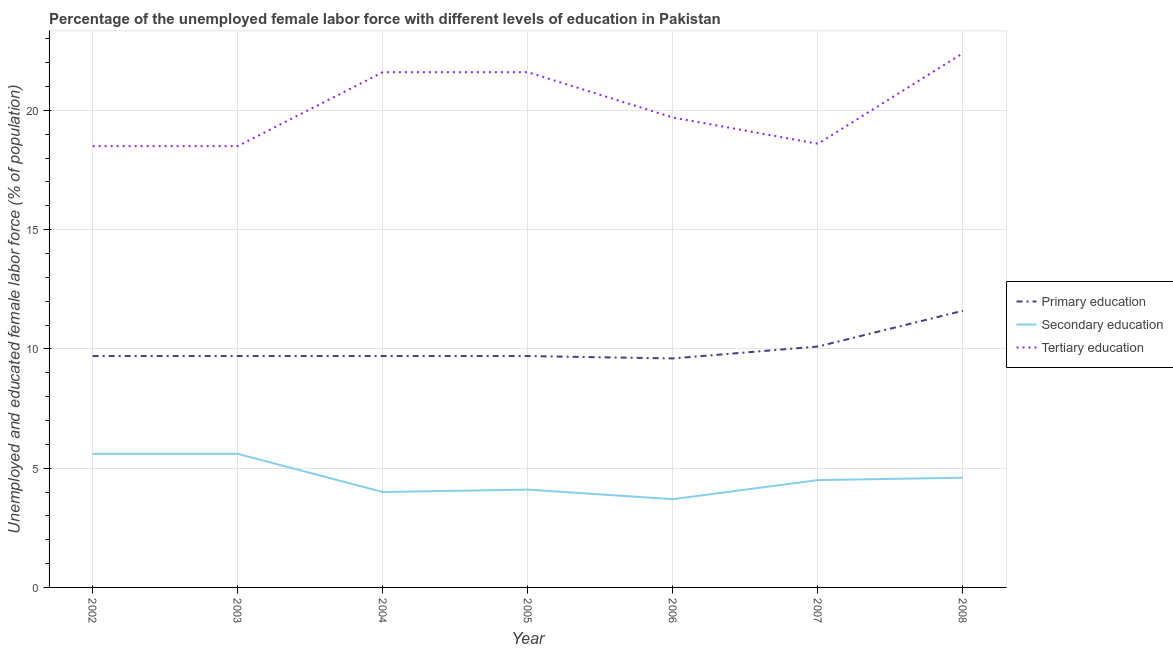How many different coloured lines are there?
Provide a short and direct response. 3. Does the line corresponding to percentage of female labor force who received tertiary education intersect with the line corresponding to percentage of female labor force who received secondary education?
Give a very brief answer. No. What is the percentage of female labor force who received primary education in 2006?
Offer a terse response. 9.6. Across all years, what is the maximum percentage of female labor force who received primary education?
Provide a succinct answer. 11.6. Across all years, what is the minimum percentage of female labor force who received tertiary education?
Your response must be concise. 18.5. In which year was the percentage of female labor force who received secondary education maximum?
Give a very brief answer. 2002. In which year was the percentage of female labor force who received primary education minimum?
Ensure brevity in your answer.  2006. What is the total percentage of female labor force who received secondary education in the graph?
Your answer should be very brief. 32.1. What is the difference between the percentage of female labor force who received tertiary education in 2003 and that in 2008?
Make the answer very short. -3.9. What is the difference between the percentage of female labor force who received tertiary education in 2005 and the percentage of female labor force who received secondary education in 2003?
Give a very brief answer. 16. What is the average percentage of female labor force who received secondary education per year?
Provide a succinct answer. 4.59. In the year 2007, what is the difference between the percentage of female labor force who received tertiary education and percentage of female labor force who received secondary education?
Your answer should be very brief. 14.1. In how many years, is the percentage of female labor force who received tertiary education greater than 22 %?
Offer a terse response. 1. What is the ratio of the percentage of female labor force who received tertiary education in 2003 to that in 2006?
Provide a short and direct response. 0.94. Is the percentage of female labor force who received tertiary education in 2002 less than that in 2003?
Your answer should be compact. No. What is the difference between the highest and the lowest percentage of female labor force who received tertiary education?
Provide a short and direct response. 3.9. In how many years, is the percentage of female labor force who received tertiary education greater than the average percentage of female labor force who received tertiary education taken over all years?
Your answer should be compact. 3. Is the sum of the percentage of female labor force who received secondary education in 2005 and 2008 greater than the maximum percentage of female labor force who received primary education across all years?
Ensure brevity in your answer.  No. Is it the case that in every year, the sum of the percentage of female labor force who received primary education and percentage of female labor force who received secondary education is greater than the percentage of female labor force who received tertiary education?
Make the answer very short. No. Does the percentage of female labor force who received tertiary education monotonically increase over the years?
Ensure brevity in your answer.  No. How many years are there in the graph?
Make the answer very short. 7. What is the difference between two consecutive major ticks on the Y-axis?
Give a very brief answer. 5. Are the values on the major ticks of Y-axis written in scientific E-notation?
Your answer should be very brief. No. Does the graph contain any zero values?
Give a very brief answer. No. Does the graph contain grids?
Offer a very short reply. Yes. What is the title of the graph?
Provide a succinct answer. Percentage of the unemployed female labor force with different levels of education in Pakistan. Does "Ages 20-60" appear as one of the legend labels in the graph?
Give a very brief answer. No. What is the label or title of the X-axis?
Offer a very short reply. Year. What is the label or title of the Y-axis?
Keep it short and to the point. Unemployed and educated female labor force (% of population). What is the Unemployed and educated female labor force (% of population) in Primary education in 2002?
Provide a short and direct response. 9.7. What is the Unemployed and educated female labor force (% of population) in Secondary education in 2002?
Ensure brevity in your answer.  5.6. What is the Unemployed and educated female labor force (% of population) in Tertiary education in 2002?
Provide a short and direct response. 18.5. What is the Unemployed and educated female labor force (% of population) of Primary education in 2003?
Provide a succinct answer. 9.7. What is the Unemployed and educated female labor force (% of population) of Secondary education in 2003?
Your response must be concise. 5.6. What is the Unemployed and educated female labor force (% of population) in Tertiary education in 2003?
Offer a very short reply. 18.5. What is the Unemployed and educated female labor force (% of population) of Primary education in 2004?
Your answer should be very brief. 9.7. What is the Unemployed and educated female labor force (% of population) in Secondary education in 2004?
Offer a very short reply. 4. What is the Unemployed and educated female labor force (% of population) in Tertiary education in 2004?
Make the answer very short. 21.6. What is the Unemployed and educated female labor force (% of population) in Primary education in 2005?
Provide a short and direct response. 9.7. What is the Unemployed and educated female labor force (% of population) in Secondary education in 2005?
Ensure brevity in your answer.  4.1. What is the Unemployed and educated female labor force (% of population) in Tertiary education in 2005?
Your answer should be very brief. 21.6. What is the Unemployed and educated female labor force (% of population) of Primary education in 2006?
Offer a very short reply. 9.6. What is the Unemployed and educated female labor force (% of population) in Secondary education in 2006?
Offer a very short reply. 3.7. What is the Unemployed and educated female labor force (% of population) of Tertiary education in 2006?
Keep it short and to the point. 19.7. What is the Unemployed and educated female labor force (% of population) in Primary education in 2007?
Make the answer very short. 10.1. What is the Unemployed and educated female labor force (% of population) in Tertiary education in 2007?
Provide a short and direct response. 18.6. What is the Unemployed and educated female labor force (% of population) of Primary education in 2008?
Offer a very short reply. 11.6. What is the Unemployed and educated female labor force (% of population) of Secondary education in 2008?
Provide a short and direct response. 4.6. What is the Unemployed and educated female labor force (% of population) of Tertiary education in 2008?
Ensure brevity in your answer.  22.4. Across all years, what is the maximum Unemployed and educated female labor force (% of population) in Primary education?
Make the answer very short. 11.6. Across all years, what is the maximum Unemployed and educated female labor force (% of population) of Secondary education?
Offer a terse response. 5.6. Across all years, what is the maximum Unemployed and educated female labor force (% of population) in Tertiary education?
Your answer should be very brief. 22.4. Across all years, what is the minimum Unemployed and educated female labor force (% of population) in Primary education?
Offer a very short reply. 9.6. Across all years, what is the minimum Unemployed and educated female labor force (% of population) of Secondary education?
Make the answer very short. 3.7. What is the total Unemployed and educated female labor force (% of population) of Primary education in the graph?
Ensure brevity in your answer.  70.1. What is the total Unemployed and educated female labor force (% of population) in Secondary education in the graph?
Keep it short and to the point. 32.1. What is the total Unemployed and educated female labor force (% of population) of Tertiary education in the graph?
Provide a short and direct response. 140.9. What is the difference between the Unemployed and educated female labor force (% of population) in Secondary education in 2002 and that in 2003?
Offer a very short reply. 0. What is the difference between the Unemployed and educated female labor force (% of population) of Tertiary education in 2002 and that in 2003?
Your answer should be very brief. 0. What is the difference between the Unemployed and educated female labor force (% of population) in Primary education in 2002 and that in 2004?
Provide a short and direct response. 0. What is the difference between the Unemployed and educated female labor force (% of population) in Secondary education in 2002 and that in 2004?
Provide a succinct answer. 1.6. What is the difference between the Unemployed and educated female labor force (% of population) in Secondary education in 2002 and that in 2005?
Make the answer very short. 1.5. What is the difference between the Unemployed and educated female labor force (% of population) in Primary education in 2002 and that in 2006?
Your answer should be compact. 0.1. What is the difference between the Unemployed and educated female labor force (% of population) of Tertiary education in 2002 and that in 2006?
Provide a succinct answer. -1.2. What is the difference between the Unemployed and educated female labor force (% of population) of Primary education in 2002 and that in 2007?
Provide a short and direct response. -0.4. What is the difference between the Unemployed and educated female labor force (% of population) in Primary education in 2002 and that in 2008?
Ensure brevity in your answer.  -1.9. What is the difference between the Unemployed and educated female labor force (% of population) of Tertiary education in 2003 and that in 2004?
Give a very brief answer. -3.1. What is the difference between the Unemployed and educated female labor force (% of population) of Primary education in 2003 and that in 2005?
Offer a terse response. 0. What is the difference between the Unemployed and educated female labor force (% of population) in Secondary education in 2003 and that in 2005?
Your answer should be very brief. 1.5. What is the difference between the Unemployed and educated female labor force (% of population) in Primary education in 2003 and that in 2006?
Your answer should be very brief. 0.1. What is the difference between the Unemployed and educated female labor force (% of population) of Secondary education in 2003 and that in 2006?
Provide a short and direct response. 1.9. What is the difference between the Unemployed and educated female labor force (% of population) of Primary education in 2003 and that in 2007?
Provide a succinct answer. -0.4. What is the difference between the Unemployed and educated female labor force (% of population) in Secondary education in 2003 and that in 2007?
Offer a very short reply. 1.1. What is the difference between the Unemployed and educated female labor force (% of population) in Primary education in 2003 and that in 2008?
Your answer should be very brief. -1.9. What is the difference between the Unemployed and educated female labor force (% of population) of Secondary education in 2003 and that in 2008?
Your answer should be compact. 1. What is the difference between the Unemployed and educated female labor force (% of population) of Primary education in 2004 and that in 2005?
Provide a succinct answer. 0. What is the difference between the Unemployed and educated female labor force (% of population) of Secondary education in 2004 and that in 2005?
Provide a short and direct response. -0.1. What is the difference between the Unemployed and educated female labor force (% of population) in Tertiary education in 2004 and that in 2005?
Your answer should be compact. 0. What is the difference between the Unemployed and educated female labor force (% of population) in Primary education in 2004 and that in 2006?
Offer a very short reply. 0.1. What is the difference between the Unemployed and educated female labor force (% of population) in Secondary education in 2004 and that in 2006?
Provide a short and direct response. 0.3. What is the difference between the Unemployed and educated female labor force (% of population) of Tertiary education in 2004 and that in 2006?
Give a very brief answer. 1.9. What is the difference between the Unemployed and educated female labor force (% of population) of Primary education in 2004 and that in 2007?
Offer a very short reply. -0.4. What is the difference between the Unemployed and educated female labor force (% of population) in Tertiary education in 2004 and that in 2007?
Your response must be concise. 3. What is the difference between the Unemployed and educated female labor force (% of population) in Primary education in 2004 and that in 2008?
Offer a terse response. -1.9. What is the difference between the Unemployed and educated female labor force (% of population) in Tertiary education in 2004 and that in 2008?
Offer a very short reply. -0.8. What is the difference between the Unemployed and educated female labor force (% of population) of Primary education in 2005 and that in 2006?
Offer a terse response. 0.1. What is the difference between the Unemployed and educated female labor force (% of population) of Secondary education in 2005 and that in 2006?
Make the answer very short. 0.4. What is the difference between the Unemployed and educated female labor force (% of population) of Tertiary education in 2005 and that in 2006?
Make the answer very short. 1.9. What is the difference between the Unemployed and educated female labor force (% of population) in Secondary education in 2005 and that in 2008?
Provide a short and direct response. -0.5. What is the difference between the Unemployed and educated female labor force (% of population) of Primary education in 2006 and that in 2007?
Keep it short and to the point. -0.5. What is the difference between the Unemployed and educated female labor force (% of population) of Secondary education in 2006 and that in 2007?
Provide a succinct answer. -0.8. What is the difference between the Unemployed and educated female labor force (% of population) of Tertiary education in 2006 and that in 2007?
Provide a short and direct response. 1.1. What is the difference between the Unemployed and educated female labor force (% of population) in Tertiary education in 2007 and that in 2008?
Provide a short and direct response. -3.8. What is the difference between the Unemployed and educated female labor force (% of population) of Primary education in 2002 and the Unemployed and educated female labor force (% of population) of Secondary education in 2003?
Your answer should be very brief. 4.1. What is the difference between the Unemployed and educated female labor force (% of population) in Secondary education in 2002 and the Unemployed and educated female labor force (% of population) in Tertiary education in 2003?
Give a very brief answer. -12.9. What is the difference between the Unemployed and educated female labor force (% of population) in Primary education in 2002 and the Unemployed and educated female labor force (% of population) in Secondary education in 2004?
Provide a short and direct response. 5.7. What is the difference between the Unemployed and educated female labor force (% of population) in Primary education in 2002 and the Unemployed and educated female labor force (% of population) in Tertiary education in 2004?
Offer a very short reply. -11.9. What is the difference between the Unemployed and educated female labor force (% of population) in Primary education in 2002 and the Unemployed and educated female labor force (% of population) in Secondary education in 2005?
Provide a succinct answer. 5.6. What is the difference between the Unemployed and educated female labor force (% of population) of Primary education in 2002 and the Unemployed and educated female labor force (% of population) of Tertiary education in 2005?
Offer a terse response. -11.9. What is the difference between the Unemployed and educated female labor force (% of population) of Primary education in 2002 and the Unemployed and educated female labor force (% of population) of Tertiary education in 2006?
Offer a terse response. -10. What is the difference between the Unemployed and educated female labor force (% of population) in Secondary education in 2002 and the Unemployed and educated female labor force (% of population) in Tertiary education in 2006?
Ensure brevity in your answer.  -14.1. What is the difference between the Unemployed and educated female labor force (% of population) in Primary education in 2002 and the Unemployed and educated female labor force (% of population) in Secondary education in 2008?
Provide a succinct answer. 5.1. What is the difference between the Unemployed and educated female labor force (% of population) of Primary education in 2002 and the Unemployed and educated female labor force (% of population) of Tertiary education in 2008?
Make the answer very short. -12.7. What is the difference between the Unemployed and educated female labor force (% of population) in Secondary education in 2002 and the Unemployed and educated female labor force (% of population) in Tertiary education in 2008?
Your answer should be compact. -16.8. What is the difference between the Unemployed and educated female labor force (% of population) in Primary education in 2003 and the Unemployed and educated female labor force (% of population) in Secondary education in 2005?
Your response must be concise. 5.6. What is the difference between the Unemployed and educated female labor force (% of population) of Primary education in 2003 and the Unemployed and educated female labor force (% of population) of Tertiary education in 2005?
Ensure brevity in your answer.  -11.9. What is the difference between the Unemployed and educated female labor force (% of population) in Secondary education in 2003 and the Unemployed and educated female labor force (% of population) in Tertiary education in 2005?
Provide a short and direct response. -16. What is the difference between the Unemployed and educated female labor force (% of population) in Primary education in 2003 and the Unemployed and educated female labor force (% of population) in Secondary education in 2006?
Give a very brief answer. 6. What is the difference between the Unemployed and educated female labor force (% of population) of Secondary education in 2003 and the Unemployed and educated female labor force (% of population) of Tertiary education in 2006?
Your response must be concise. -14.1. What is the difference between the Unemployed and educated female labor force (% of population) in Primary education in 2003 and the Unemployed and educated female labor force (% of population) in Tertiary education in 2007?
Your answer should be compact. -8.9. What is the difference between the Unemployed and educated female labor force (% of population) of Primary education in 2003 and the Unemployed and educated female labor force (% of population) of Tertiary education in 2008?
Ensure brevity in your answer.  -12.7. What is the difference between the Unemployed and educated female labor force (% of population) in Secondary education in 2003 and the Unemployed and educated female labor force (% of population) in Tertiary education in 2008?
Offer a terse response. -16.8. What is the difference between the Unemployed and educated female labor force (% of population) in Primary education in 2004 and the Unemployed and educated female labor force (% of population) in Secondary education in 2005?
Provide a succinct answer. 5.6. What is the difference between the Unemployed and educated female labor force (% of population) of Primary education in 2004 and the Unemployed and educated female labor force (% of population) of Tertiary education in 2005?
Your answer should be compact. -11.9. What is the difference between the Unemployed and educated female labor force (% of population) in Secondary education in 2004 and the Unemployed and educated female labor force (% of population) in Tertiary education in 2005?
Your answer should be compact. -17.6. What is the difference between the Unemployed and educated female labor force (% of population) in Primary education in 2004 and the Unemployed and educated female labor force (% of population) in Secondary education in 2006?
Offer a terse response. 6. What is the difference between the Unemployed and educated female labor force (% of population) of Primary education in 2004 and the Unemployed and educated female labor force (% of population) of Tertiary education in 2006?
Ensure brevity in your answer.  -10. What is the difference between the Unemployed and educated female labor force (% of population) of Secondary education in 2004 and the Unemployed and educated female labor force (% of population) of Tertiary education in 2006?
Offer a very short reply. -15.7. What is the difference between the Unemployed and educated female labor force (% of population) in Primary education in 2004 and the Unemployed and educated female labor force (% of population) in Tertiary education in 2007?
Your answer should be very brief. -8.9. What is the difference between the Unemployed and educated female labor force (% of population) in Secondary education in 2004 and the Unemployed and educated female labor force (% of population) in Tertiary education in 2007?
Ensure brevity in your answer.  -14.6. What is the difference between the Unemployed and educated female labor force (% of population) in Primary education in 2004 and the Unemployed and educated female labor force (% of population) in Tertiary education in 2008?
Give a very brief answer. -12.7. What is the difference between the Unemployed and educated female labor force (% of population) in Secondary education in 2004 and the Unemployed and educated female labor force (% of population) in Tertiary education in 2008?
Provide a short and direct response. -18.4. What is the difference between the Unemployed and educated female labor force (% of population) of Secondary education in 2005 and the Unemployed and educated female labor force (% of population) of Tertiary education in 2006?
Your answer should be very brief. -15.6. What is the difference between the Unemployed and educated female labor force (% of population) in Primary education in 2005 and the Unemployed and educated female labor force (% of population) in Secondary education in 2007?
Make the answer very short. 5.2. What is the difference between the Unemployed and educated female labor force (% of population) of Primary education in 2005 and the Unemployed and educated female labor force (% of population) of Tertiary education in 2007?
Your response must be concise. -8.9. What is the difference between the Unemployed and educated female labor force (% of population) of Secondary education in 2005 and the Unemployed and educated female labor force (% of population) of Tertiary education in 2007?
Keep it short and to the point. -14.5. What is the difference between the Unemployed and educated female labor force (% of population) in Primary education in 2005 and the Unemployed and educated female labor force (% of population) in Secondary education in 2008?
Ensure brevity in your answer.  5.1. What is the difference between the Unemployed and educated female labor force (% of population) of Secondary education in 2005 and the Unemployed and educated female labor force (% of population) of Tertiary education in 2008?
Give a very brief answer. -18.3. What is the difference between the Unemployed and educated female labor force (% of population) in Secondary education in 2006 and the Unemployed and educated female labor force (% of population) in Tertiary education in 2007?
Your answer should be compact. -14.9. What is the difference between the Unemployed and educated female labor force (% of population) in Primary education in 2006 and the Unemployed and educated female labor force (% of population) in Secondary education in 2008?
Make the answer very short. 5. What is the difference between the Unemployed and educated female labor force (% of population) of Secondary education in 2006 and the Unemployed and educated female labor force (% of population) of Tertiary education in 2008?
Provide a short and direct response. -18.7. What is the difference between the Unemployed and educated female labor force (% of population) in Primary education in 2007 and the Unemployed and educated female labor force (% of population) in Secondary education in 2008?
Give a very brief answer. 5.5. What is the difference between the Unemployed and educated female labor force (% of population) in Secondary education in 2007 and the Unemployed and educated female labor force (% of population) in Tertiary education in 2008?
Your answer should be very brief. -17.9. What is the average Unemployed and educated female labor force (% of population) in Primary education per year?
Offer a very short reply. 10.01. What is the average Unemployed and educated female labor force (% of population) in Secondary education per year?
Offer a very short reply. 4.59. What is the average Unemployed and educated female labor force (% of population) in Tertiary education per year?
Offer a terse response. 20.13. In the year 2002, what is the difference between the Unemployed and educated female labor force (% of population) in Secondary education and Unemployed and educated female labor force (% of population) in Tertiary education?
Your answer should be very brief. -12.9. In the year 2003, what is the difference between the Unemployed and educated female labor force (% of population) in Primary education and Unemployed and educated female labor force (% of population) in Secondary education?
Ensure brevity in your answer.  4.1. In the year 2003, what is the difference between the Unemployed and educated female labor force (% of population) of Secondary education and Unemployed and educated female labor force (% of population) of Tertiary education?
Offer a terse response. -12.9. In the year 2004, what is the difference between the Unemployed and educated female labor force (% of population) in Primary education and Unemployed and educated female labor force (% of population) in Secondary education?
Give a very brief answer. 5.7. In the year 2004, what is the difference between the Unemployed and educated female labor force (% of population) in Primary education and Unemployed and educated female labor force (% of population) in Tertiary education?
Offer a very short reply. -11.9. In the year 2004, what is the difference between the Unemployed and educated female labor force (% of population) in Secondary education and Unemployed and educated female labor force (% of population) in Tertiary education?
Your response must be concise. -17.6. In the year 2005, what is the difference between the Unemployed and educated female labor force (% of population) of Primary education and Unemployed and educated female labor force (% of population) of Secondary education?
Provide a succinct answer. 5.6. In the year 2005, what is the difference between the Unemployed and educated female labor force (% of population) in Secondary education and Unemployed and educated female labor force (% of population) in Tertiary education?
Make the answer very short. -17.5. In the year 2006, what is the difference between the Unemployed and educated female labor force (% of population) in Primary education and Unemployed and educated female labor force (% of population) in Secondary education?
Provide a succinct answer. 5.9. In the year 2006, what is the difference between the Unemployed and educated female labor force (% of population) in Secondary education and Unemployed and educated female labor force (% of population) in Tertiary education?
Ensure brevity in your answer.  -16. In the year 2007, what is the difference between the Unemployed and educated female labor force (% of population) in Primary education and Unemployed and educated female labor force (% of population) in Tertiary education?
Ensure brevity in your answer.  -8.5. In the year 2007, what is the difference between the Unemployed and educated female labor force (% of population) of Secondary education and Unemployed and educated female labor force (% of population) of Tertiary education?
Offer a very short reply. -14.1. In the year 2008, what is the difference between the Unemployed and educated female labor force (% of population) of Primary education and Unemployed and educated female labor force (% of population) of Tertiary education?
Offer a very short reply. -10.8. In the year 2008, what is the difference between the Unemployed and educated female labor force (% of population) of Secondary education and Unemployed and educated female labor force (% of population) of Tertiary education?
Provide a short and direct response. -17.8. What is the ratio of the Unemployed and educated female labor force (% of population) in Secondary education in 2002 to that in 2003?
Provide a succinct answer. 1. What is the ratio of the Unemployed and educated female labor force (% of population) in Tertiary education in 2002 to that in 2003?
Your response must be concise. 1. What is the ratio of the Unemployed and educated female labor force (% of population) in Secondary education in 2002 to that in 2004?
Provide a succinct answer. 1.4. What is the ratio of the Unemployed and educated female labor force (% of population) of Tertiary education in 2002 to that in 2004?
Make the answer very short. 0.86. What is the ratio of the Unemployed and educated female labor force (% of population) of Primary education in 2002 to that in 2005?
Your answer should be very brief. 1. What is the ratio of the Unemployed and educated female labor force (% of population) in Secondary education in 2002 to that in 2005?
Keep it short and to the point. 1.37. What is the ratio of the Unemployed and educated female labor force (% of population) in Tertiary education in 2002 to that in 2005?
Offer a terse response. 0.86. What is the ratio of the Unemployed and educated female labor force (% of population) in Primary education in 2002 to that in 2006?
Your answer should be very brief. 1.01. What is the ratio of the Unemployed and educated female labor force (% of population) in Secondary education in 2002 to that in 2006?
Give a very brief answer. 1.51. What is the ratio of the Unemployed and educated female labor force (% of population) of Tertiary education in 2002 to that in 2006?
Offer a terse response. 0.94. What is the ratio of the Unemployed and educated female labor force (% of population) of Primary education in 2002 to that in 2007?
Your response must be concise. 0.96. What is the ratio of the Unemployed and educated female labor force (% of population) of Secondary education in 2002 to that in 2007?
Make the answer very short. 1.24. What is the ratio of the Unemployed and educated female labor force (% of population) in Tertiary education in 2002 to that in 2007?
Provide a short and direct response. 0.99. What is the ratio of the Unemployed and educated female labor force (% of population) of Primary education in 2002 to that in 2008?
Make the answer very short. 0.84. What is the ratio of the Unemployed and educated female labor force (% of population) of Secondary education in 2002 to that in 2008?
Your response must be concise. 1.22. What is the ratio of the Unemployed and educated female labor force (% of population) of Tertiary education in 2002 to that in 2008?
Your response must be concise. 0.83. What is the ratio of the Unemployed and educated female labor force (% of population) in Primary education in 2003 to that in 2004?
Your response must be concise. 1. What is the ratio of the Unemployed and educated female labor force (% of population) of Secondary education in 2003 to that in 2004?
Ensure brevity in your answer.  1.4. What is the ratio of the Unemployed and educated female labor force (% of population) in Tertiary education in 2003 to that in 2004?
Keep it short and to the point. 0.86. What is the ratio of the Unemployed and educated female labor force (% of population) in Primary education in 2003 to that in 2005?
Keep it short and to the point. 1. What is the ratio of the Unemployed and educated female labor force (% of population) in Secondary education in 2003 to that in 2005?
Offer a very short reply. 1.37. What is the ratio of the Unemployed and educated female labor force (% of population) of Tertiary education in 2003 to that in 2005?
Keep it short and to the point. 0.86. What is the ratio of the Unemployed and educated female labor force (% of population) of Primary education in 2003 to that in 2006?
Your response must be concise. 1.01. What is the ratio of the Unemployed and educated female labor force (% of population) of Secondary education in 2003 to that in 2006?
Keep it short and to the point. 1.51. What is the ratio of the Unemployed and educated female labor force (% of population) in Tertiary education in 2003 to that in 2006?
Give a very brief answer. 0.94. What is the ratio of the Unemployed and educated female labor force (% of population) in Primary education in 2003 to that in 2007?
Your answer should be very brief. 0.96. What is the ratio of the Unemployed and educated female labor force (% of population) in Secondary education in 2003 to that in 2007?
Your response must be concise. 1.24. What is the ratio of the Unemployed and educated female labor force (% of population) of Tertiary education in 2003 to that in 2007?
Your answer should be very brief. 0.99. What is the ratio of the Unemployed and educated female labor force (% of population) in Primary education in 2003 to that in 2008?
Make the answer very short. 0.84. What is the ratio of the Unemployed and educated female labor force (% of population) of Secondary education in 2003 to that in 2008?
Offer a terse response. 1.22. What is the ratio of the Unemployed and educated female labor force (% of population) in Tertiary education in 2003 to that in 2008?
Your answer should be compact. 0.83. What is the ratio of the Unemployed and educated female labor force (% of population) in Secondary education in 2004 to that in 2005?
Offer a terse response. 0.98. What is the ratio of the Unemployed and educated female labor force (% of population) of Primary education in 2004 to that in 2006?
Make the answer very short. 1.01. What is the ratio of the Unemployed and educated female labor force (% of population) in Secondary education in 2004 to that in 2006?
Give a very brief answer. 1.08. What is the ratio of the Unemployed and educated female labor force (% of population) in Tertiary education in 2004 to that in 2006?
Keep it short and to the point. 1.1. What is the ratio of the Unemployed and educated female labor force (% of population) of Primary education in 2004 to that in 2007?
Provide a succinct answer. 0.96. What is the ratio of the Unemployed and educated female labor force (% of population) of Secondary education in 2004 to that in 2007?
Provide a short and direct response. 0.89. What is the ratio of the Unemployed and educated female labor force (% of population) in Tertiary education in 2004 to that in 2007?
Keep it short and to the point. 1.16. What is the ratio of the Unemployed and educated female labor force (% of population) in Primary education in 2004 to that in 2008?
Provide a succinct answer. 0.84. What is the ratio of the Unemployed and educated female labor force (% of population) of Secondary education in 2004 to that in 2008?
Offer a terse response. 0.87. What is the ratio of the Unemployed and educated female labor force (% of population) in Primary education in 2005 to that in 2006?
Provide a succinct answer. 1.01. What is the ratio of the Unemployed and educated female labor force (% of population) of Secondary education in 2005 to that in 2006?
Your answer should be compact. 1.11. What is the ratio of the Unemployed and educated female labor force (% of population) in Tertiary education in 2005 to that in 2006?
Your answer should be compact. 1.1. What is the ratio of the Unemployed and educated female labor force (% of population) of Primary education in 2005 to that in 2007?
Provide a short and direct response. 0.96. What is the ratio of the Unemployed and educated female labor force (% of population) of Secondary education in 2005 to that in 2007?
Keep it short and to the point. 0.91. What is the ratio of the Unemployed and educated female labor force (% of population) in Tertiary education in 2005 to that in 2007?
Provide a succinct answer. 1.16. What is the ratio of the Unemployed and educated female labor force (% of population) of Primary education in 2005 to that in 2008?
Your answer should be compact. 0.84. What is the ratio of the Unemployed and educated female labor force (% of population) of Secondary education in 2005 to that in 2008?
Offer a terse response. 0.89. What is the ratio of the Unemployed and educated female labor force (% of population) in Tertiary education in 2005 to that in 2008?
Offer a terse response. 0.96. What is the ratio of the Unemployed and educated female labor force (% of population) in Primary education in 2006 to that in 2007?
Give a very brief answer. 0.95. What is the ratio of the Unemployed and educated female labor force (% of population) of Secondary education in 2006 to that in 2007?
Offer a terse response. 0.82. What is the ratio of the Unemployed and educated female labor force (% of population) in Tertiary education in 2006 to that in 2007?
Ensure brevity in your answer.  1.06. What is the ratio of the Unemployed and educated female labor force (% of population) in Primary education in 2006 to that in 2008?
Provide a succinct answer. 0.83. What is the ratio of the Unemployed and educated female labor force (% of population) of Secondary education in 2006 to that in 2008?
Your answer should be compact. 0.8. What is the ratio of the Unemployed and educated female labor force (% of population) of Tertiary education in 2006 to that in 2008?
Provide a short and direct response. 0.88. What is the ratio of the Unemployed and educated female labor force (% of population) of Primary education in 2007 to that in 2008?
Your answer should be very brief. 0.87. What is the ratio of the Unemployed and educated female labor force (% of population) in Secondary education in 2007 to that in 2008?
Provide a succinct answer. 0.98. What is the ratio of the Unemployed and educated female labor force (% of population) of Tertiary education in 2007 to that in 2008?
Ensure brevity in your answer.  0.83. What is the difference between the highest and the second highest Unemployed and educated female labor force (% of population) of Primary education?
Keep it short and to the point. 1.5. What is the difference between the highest and the second highest Unemployed and educated female labor force (% of population) in Secondary education?
Provide a succinct answer. 0. What is the difference between the highest and the lowest Unemployed and educated female labor force (% of population) in Primary education?
Offer a terse response. 2. What is the difference between the highest and the lowest Unemployed and educated female labor force (% of population) of Secondary education?
Provide a short and direct response. 1.9. 